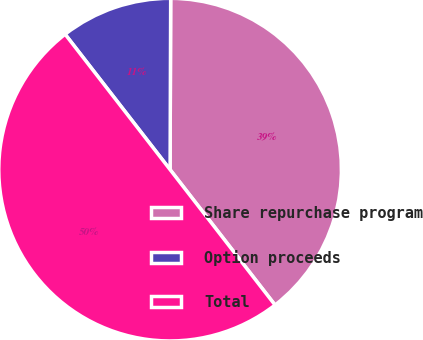Convert chart to OTSL. <chart><loc_0><loc_0><loc_500><loc_500><pie_chart><fcel>Share repurchase program<fcel>Option proceeds<fcel>Total<nl><fcel>39.45%<fcel>10.55%<fcel>50.0%<nl></chart> 